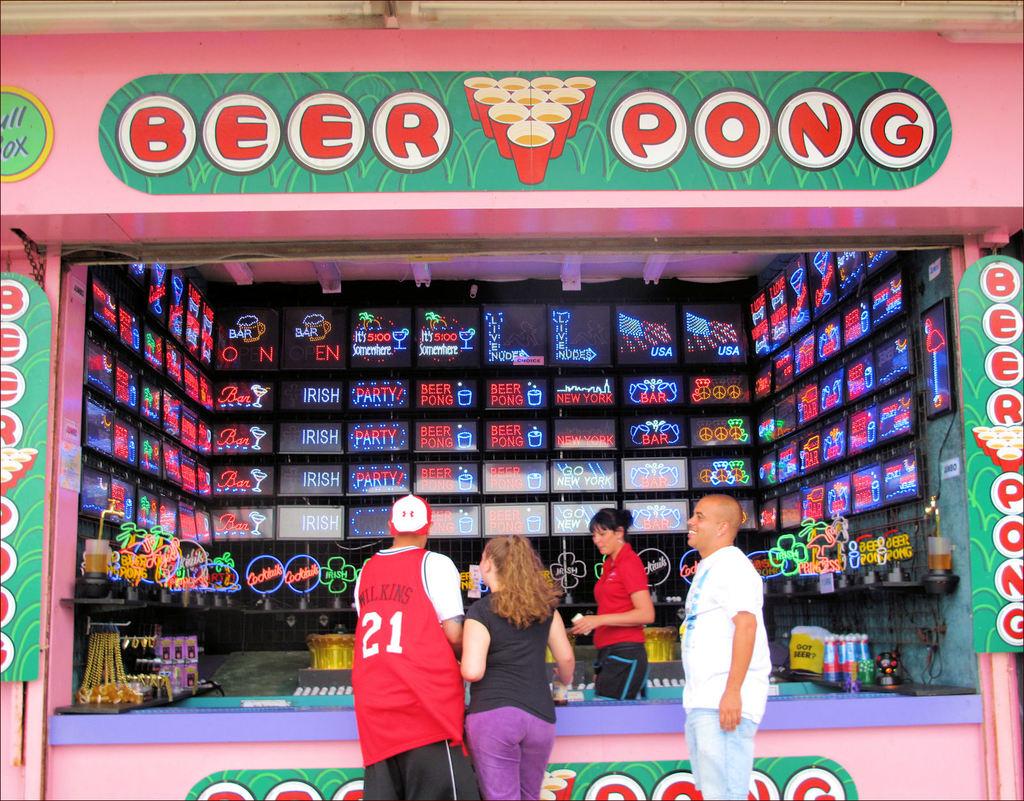What is being played here?
Your answer should be compact. Beer pong. 